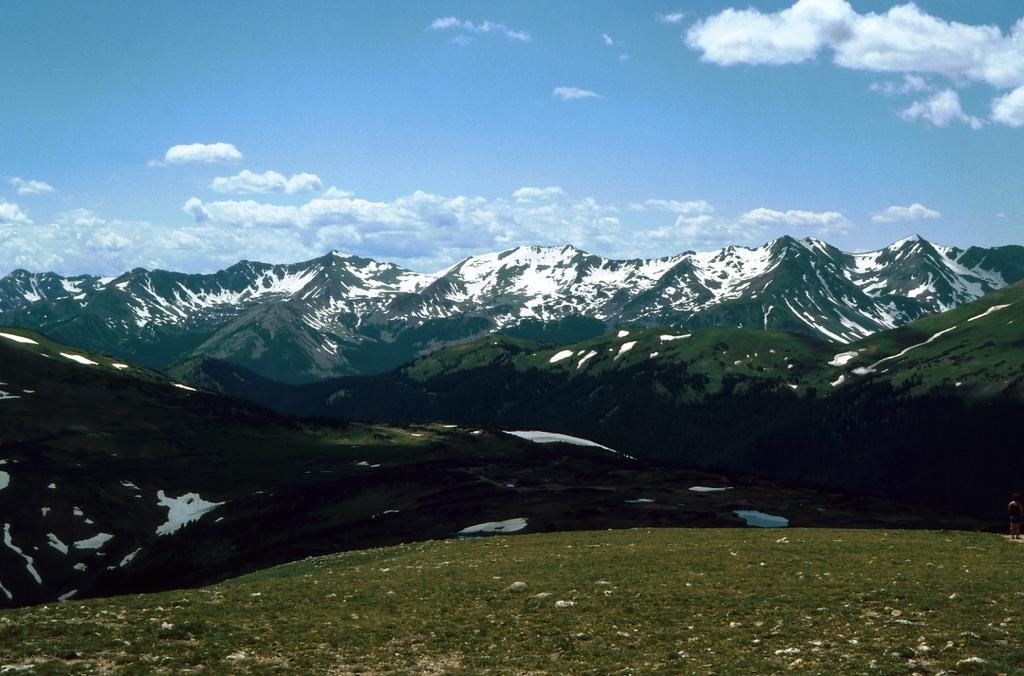Describe this image in one or two sentences. In this image I can see grass, mountains, snow, clouds and the sky in the background. 